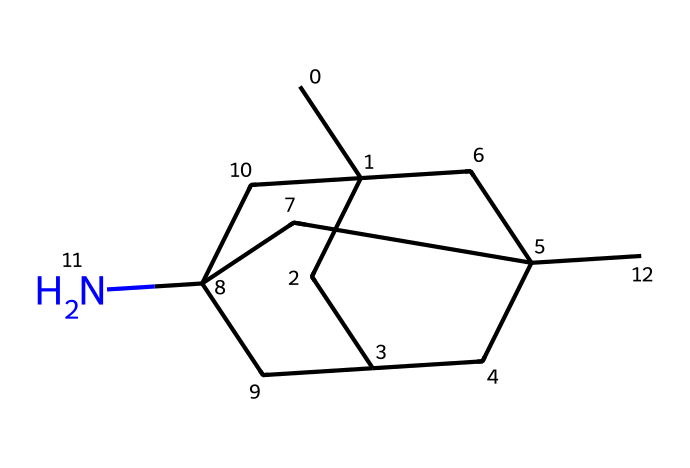How many carbon atoms are in memantine? By interpreting the SMILES representation, we can count the number of carbon (C) atoms. The "CC" at the beginning indicates at least two carbon atoms, and as we parse through the rest of the structure, we see that there are a total of 11 carbon atoms.
Answer: eleven How many nitrogen atoms are in memantine? In the provided SMILES, the letter "N" represents nitrogen. There is one instance of "N" in the structure, indicating there is one nitrogen atom in memantine.
Answer: one What functional group is present in memantine? Analyzing the structure, we see the presence of nitrogen which is characteristic of amines. However, since it is part of a cyclic structure and contributes to a more complex compound, memantine can be classified specifically as a secondary amine due to its bonding.
Answer: secondary amine What is the molecular formula of memantine? By reviewing the SMILES, we identify 11 carbon (C), 21 hydrogen (H), and 1 nitrogen (N) which combines into the molecular formula: C11H21N. This can be derived by counting each type of atom indicated in the structure.
Answer: C11H21N Is memantine a chiral compound? To determine chirality in memantine, we look for any carbon atoms that are bonded to four different substituents. In this structure, there is at least one carbon atom with this property, indicating that it is chiral, as it can have non-superimposable mirror images.
Answer: yes What type of chemical is memantine classified as? Memantine serves as an NMDA receptor antagonist, which indicates it's primarily classified as a therapeutic agent in neurology, specifically useful in Alzheimer's treatment. Therefore, based on its action and application, it can be classified as a pharmaceutical.
Answer: pharmaceutical 